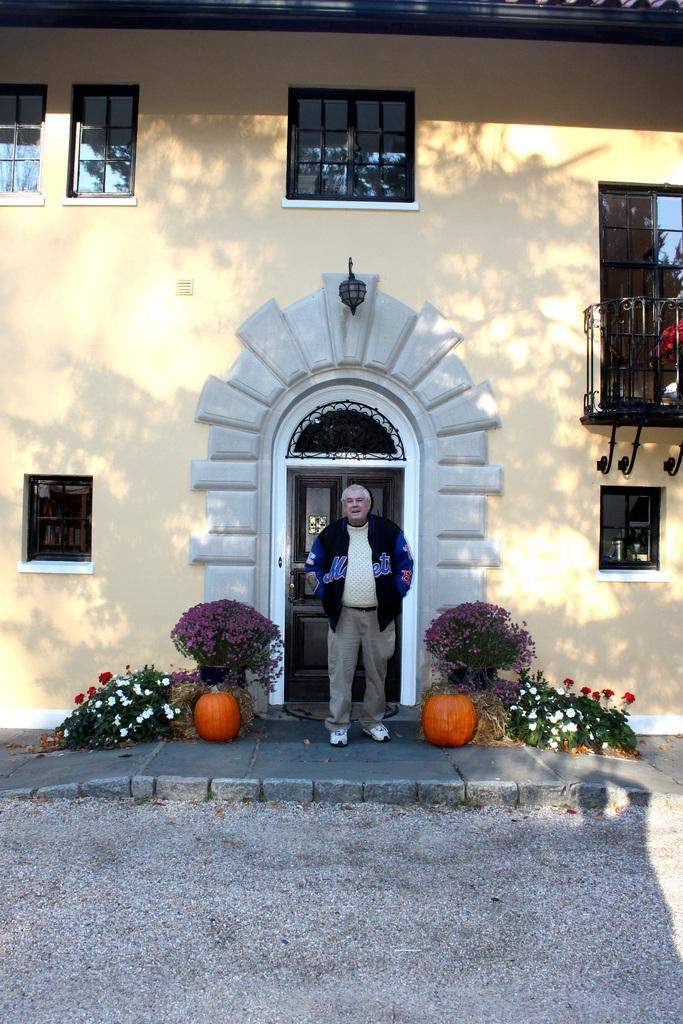What type of structure is visible in the image? There is a building with windows in the image. Can you describe the person in the image? There is a person standing in front of the building. What is present on both sides of the person? There are flowers and plants on the left and right sides of the person. What type of toy can be seen in the person's hand in the image? There is no toy visible in the person's hand in the image. Does the person have a tail in the image? The person does not have a tail in the image, as humans do not have tails. 